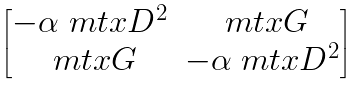<formula> <loc_0><loc_0><loc_500><loc_500>\begin{bmatrix} - \alpha \ m t x { D } ^ { 2 } & \ m t x { G } \\ \ m t x { G } & - \alpha \ m t x { D } ^ { 2 } \end{bmatrix}</formula> 